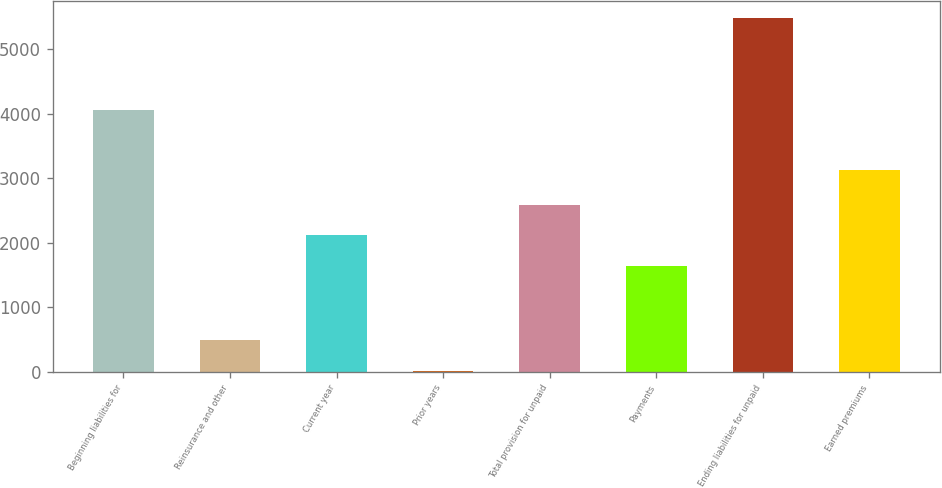Convert chart to OTSL. <chart><loc_0><loc_0><loc_500><loc_500><bar_chart><fcel>Beginning liabilities for<fcel>Reinsurance and other<fcel>Current year<fcel>Prior years<fcel>Total provision for unpaid<fcel>Payments<fcel>Ending liabilities for unpaid<fcel>Earned premiums<nl><fcel>4065<fcel>491.5<fcel>2121.5<fcel>19<fcel>2594<fcel>1649<fcel>5482.5<fcel>3126<nl></chart> 